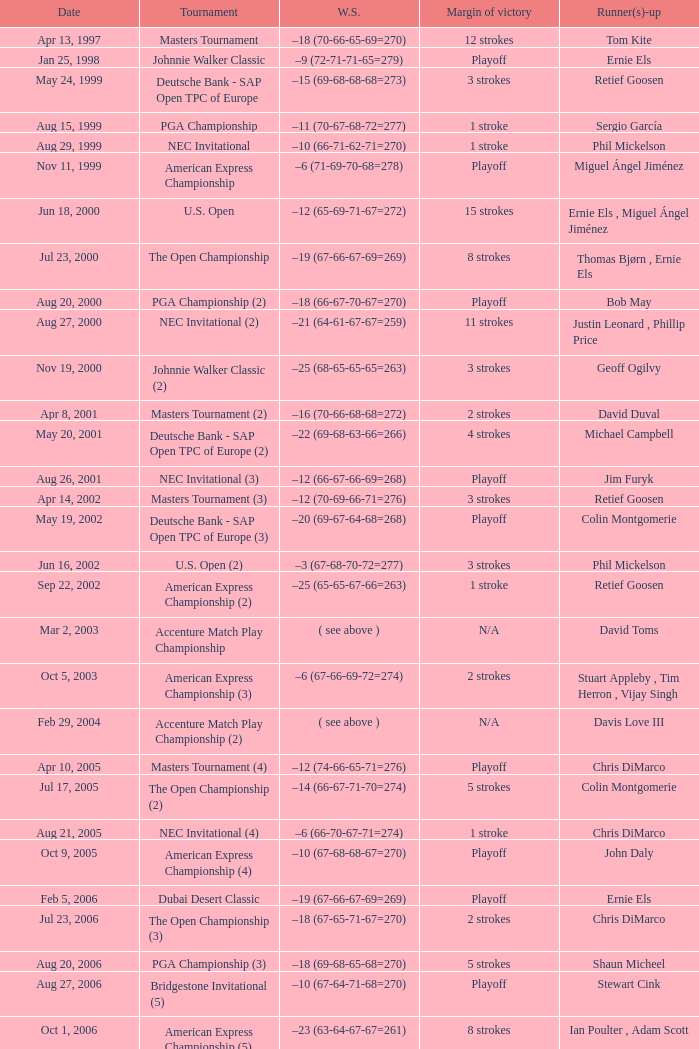Who has the Winning score of –10 (66-71-62-71=270) ? Phil Mickelson. 